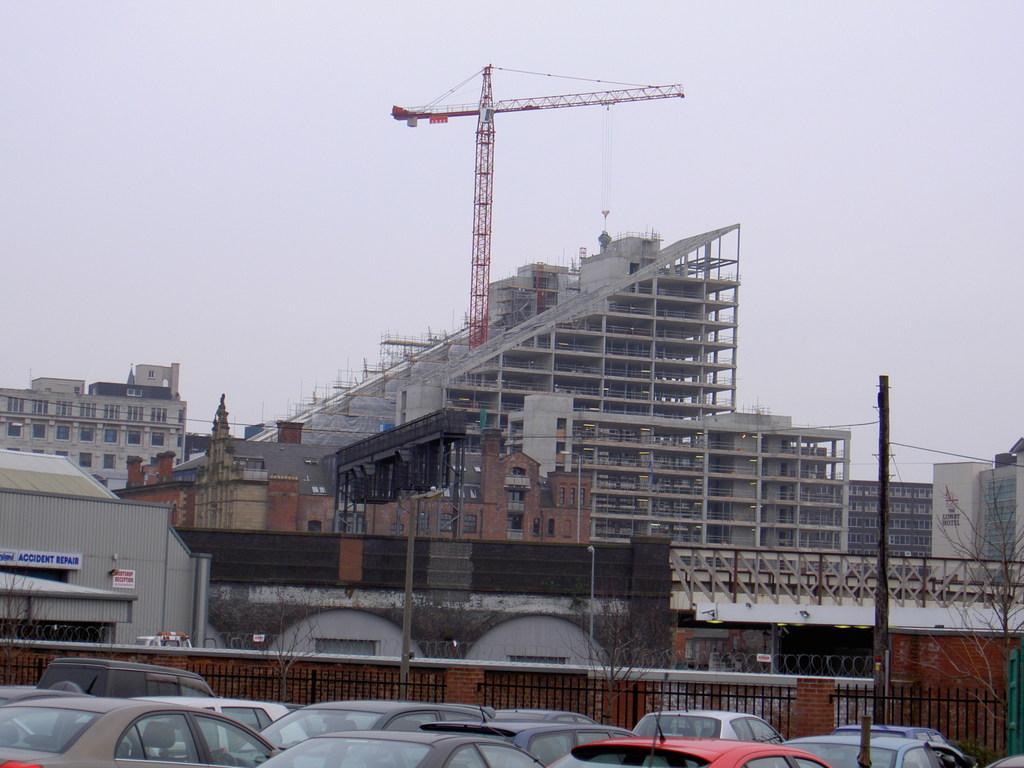Could you give a brief overview of what you see in this image? In this image we can see that there is a building under construction. Beside the building there is a crane. At the there are cars on the road. Beside the cars there is a fence. At the top there is sky. There are buildings all over the place. 